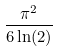Convert formula to latex. <formula><loc_0><loc_0><loc_500><loc_500>\frac { \pi ^ { 2 } } { 6 \ln ( 2 ) }</formula> 